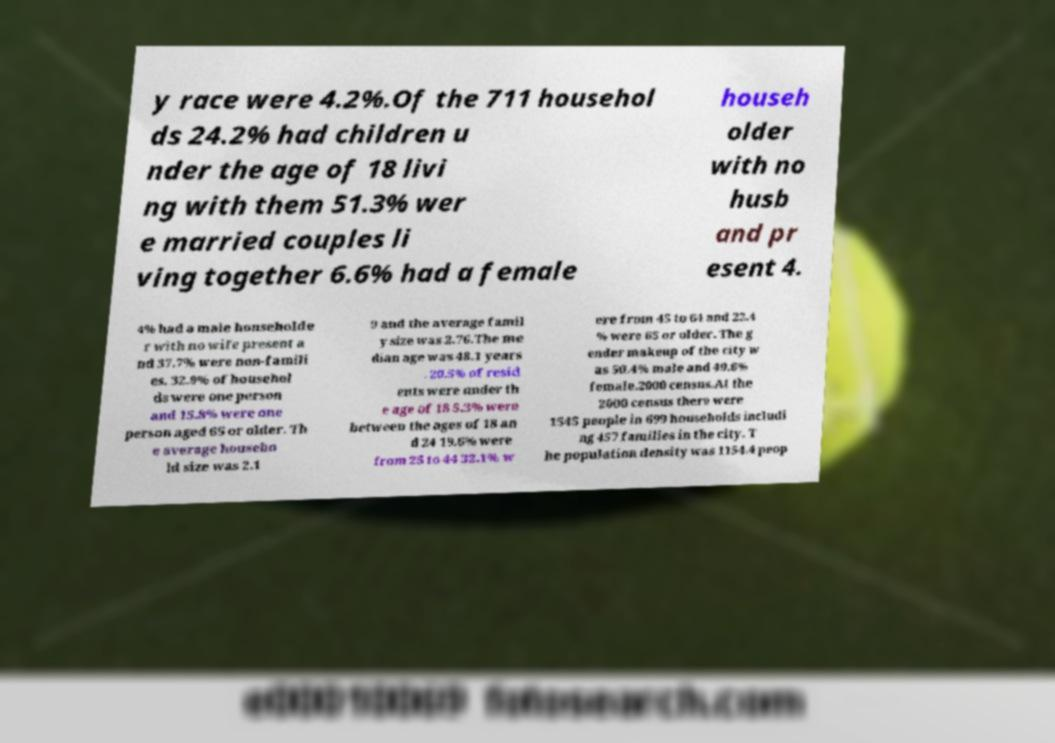Can you read and provide the text displayed in the image?This photo seems to have some interesting text. Can you extract and type it out for me? y race were 4.2%.Of the 711 househol ds 24.2% had children u nder the age of 18 livi ng with them 51.3% wer e married couples li ving together 6.6% had a female househ older with no husb and pr esent 4. 4% had a male householde r with no wife present a nd 37.7% were non-famili es. 32.9% of househol ds were one person and 15.8% were one person aged 65 or older. Th e average househo ld size was 2.1 9 and the average famil y size was 2.76.The me dian age was 48.1 years . 20.5% of resid ents were under th e age of 18 5.3% were between the ages of 18 an d 24 19.6% were from 25 to 44 32.1% w ere from 45 to 64 and 22.4 % were 65 or older. The g ender makeup of the city w as 50.4% male and 49.6% female.2000 census.At the 2000 census there were 1545 people in 699 households includi ng 457 families in the city. T he population density was 1154.4 peop 